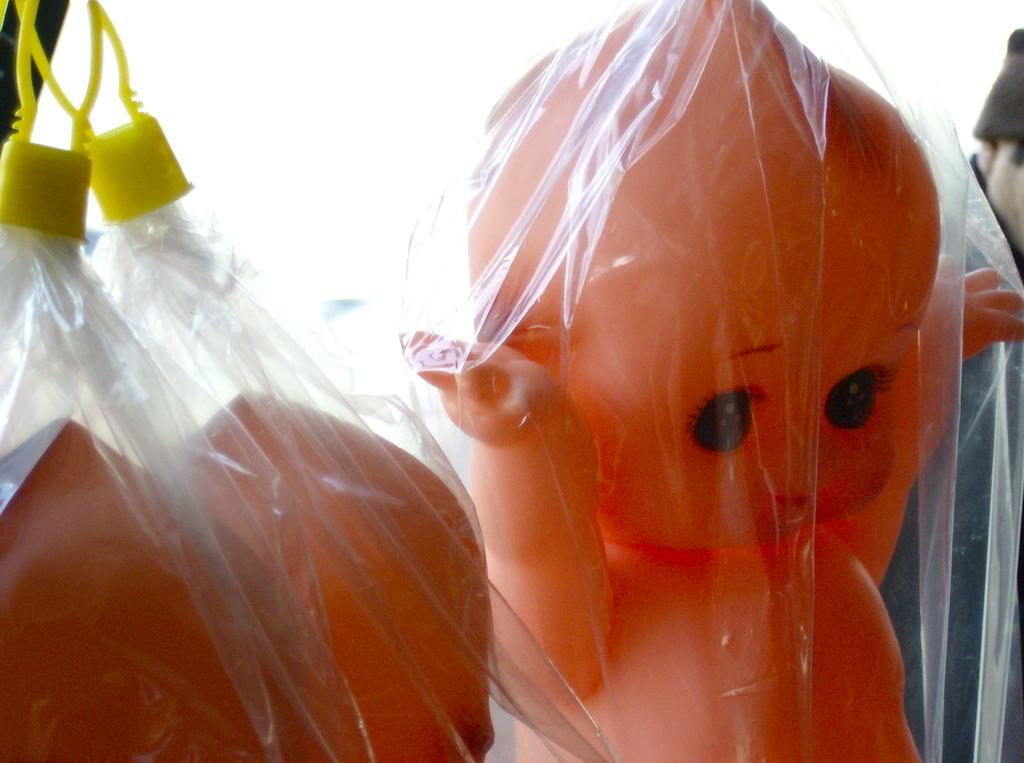What is the main subject of the image? The main subject of the image is a group of dolls. How are the dolls arranged or positioned in the image? The dolls are placed in carry bags. Can you describe anything in the background of the image? There is a person in the background of the image. What is the person wearing on their head? The person is wearing a cap. What type of cream is being used to decorate the dolls in the image? There is no cream present in the image, and the dolls are not being decorated. 